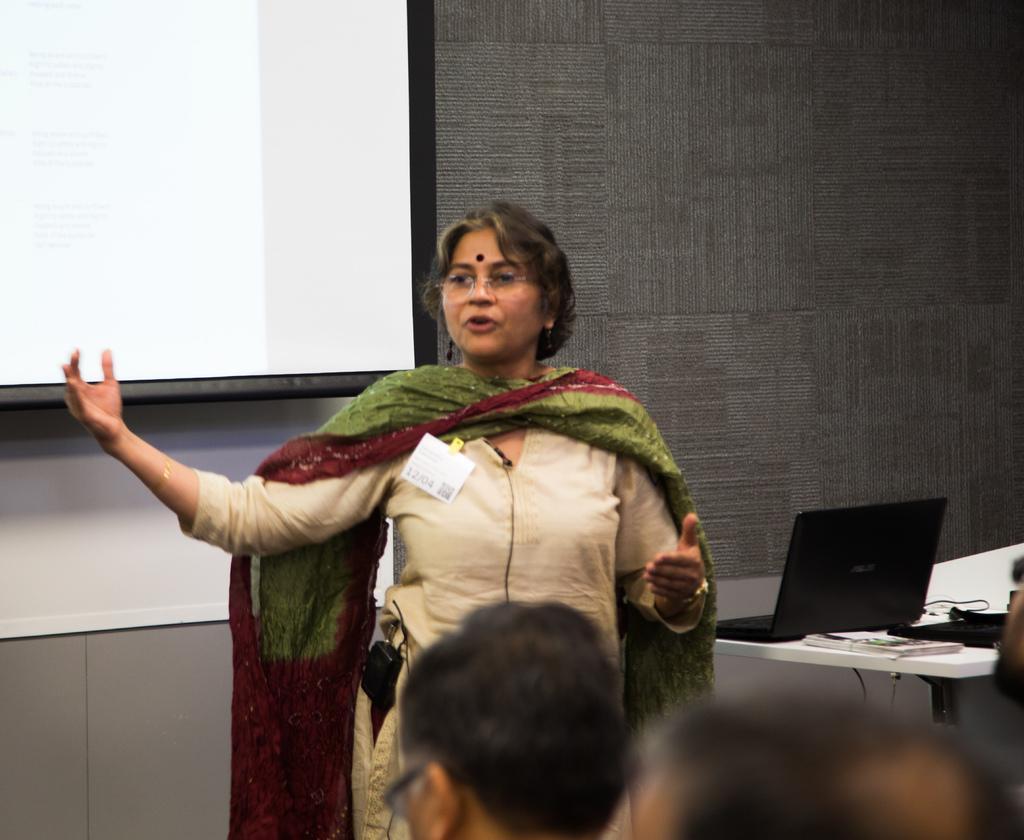Please provide a concise description of this image. In this image there is a person standing and talking. At the back there is a screen. At the right there is a laptop's, wires, books on the table. In the front there are group of people. 